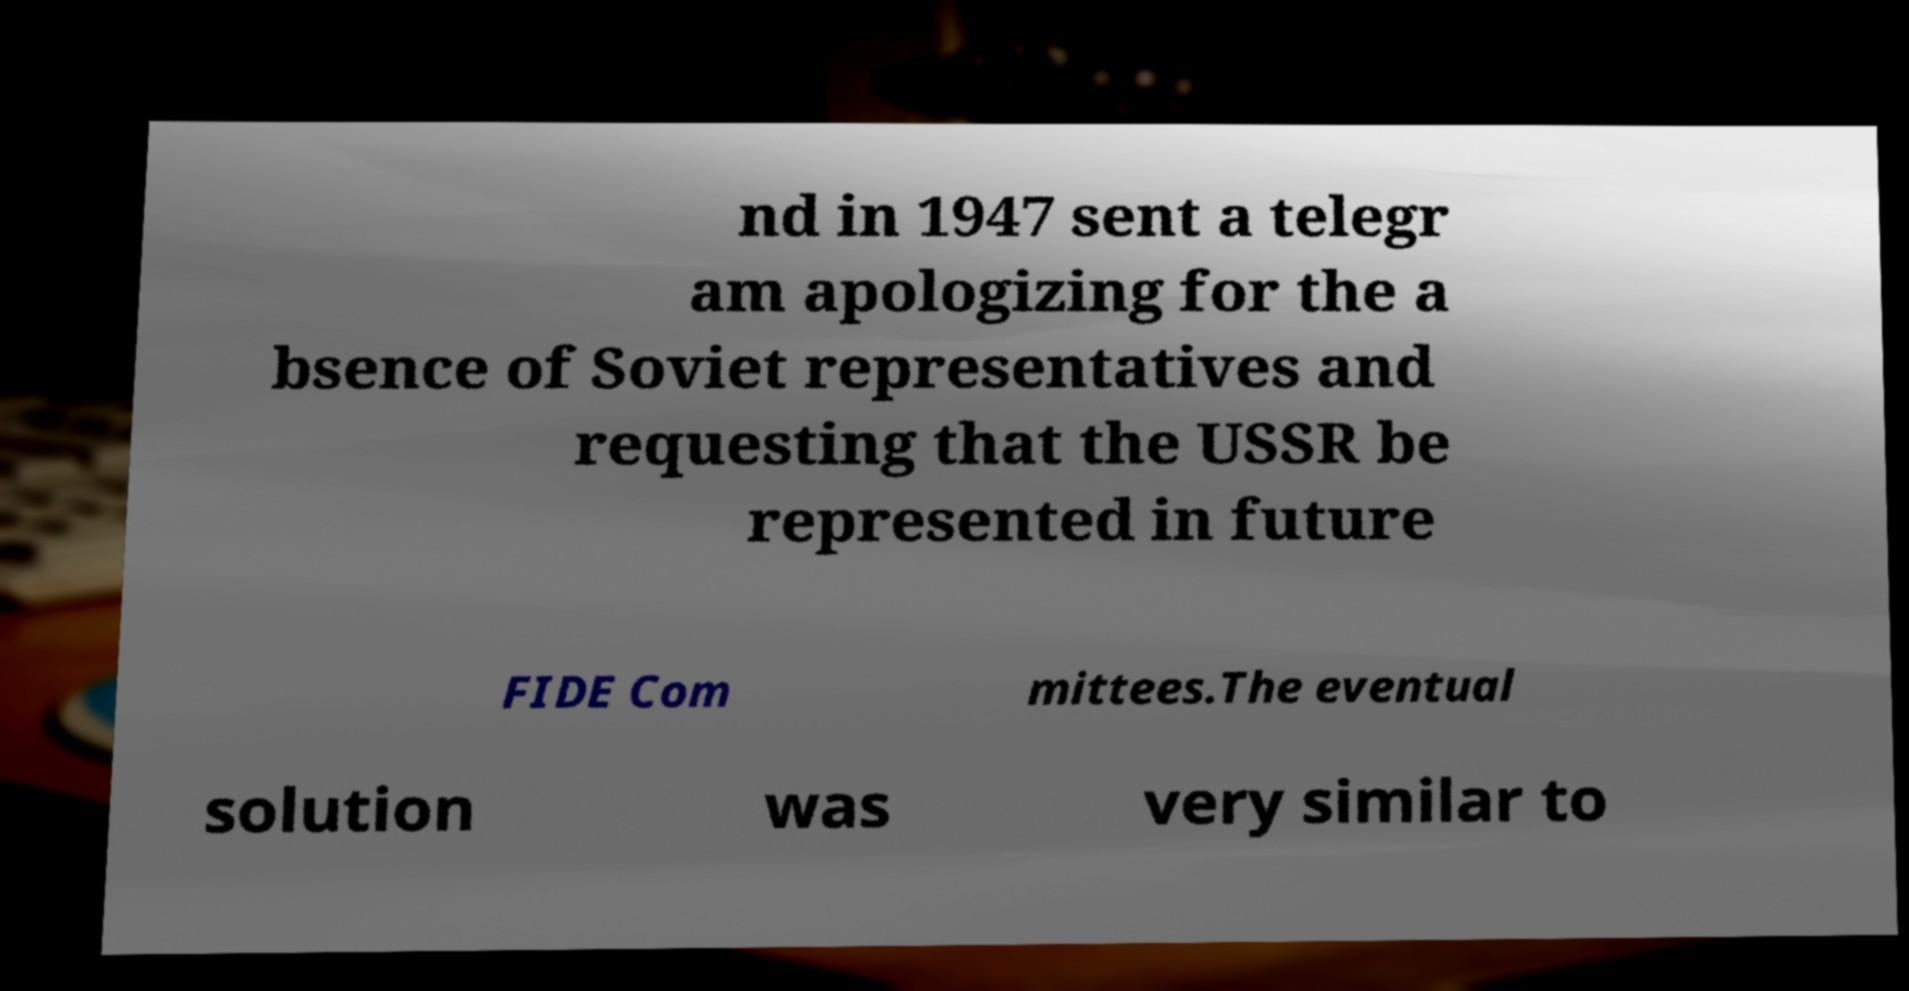Could you assist in decoding the text presented in this image and type it out clearly? nd in 1947 sent a telegr am apologizing for the a bsence of Soviet representatives and requesting that the USSR be represented in future FIDE Com mittees.The eventual solution was very similar to 